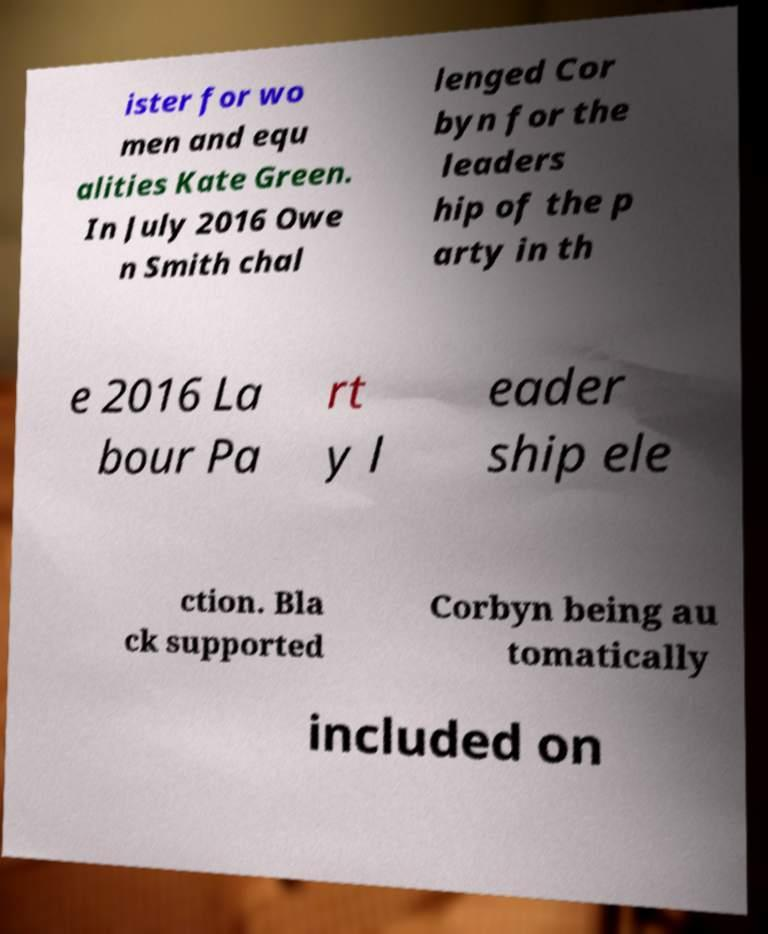Can you read and provide the text displayed in the image?This photo seems to have some interesting text. Can you extract and type it out for me? ister for wo men and equ alities Kate Green. In July 2016 Owe n Smith chal lenged Cor byn for the leaders hip of the p arty in th e 2016 La bour Pa rt y l eader ship ele ction. Bla ck supported Corbyn being au tomatically included on 